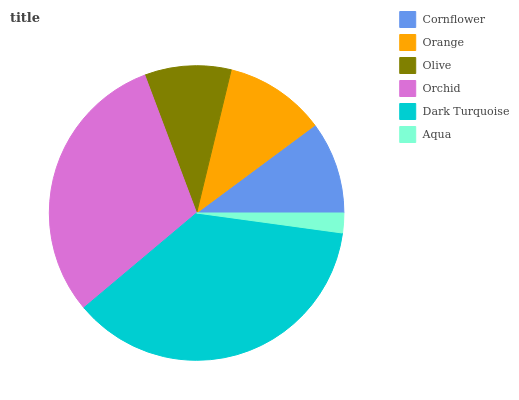Is Aqua the minimum?
Answer yes or no. Yes. Is Dark Turquoise the maximum?
Answer yes or no. Yes. Is Orange the minimum?
Answer yes or no. No. Is Orange the maximum?
Answer yes or no. No. Is Orange greater than Cornflower?
Answer yes or no. Yes. Is Cornflower less than Orange?
Answer yes or no. Yes. Is Cornflower greater than Orange?
Answer yes or no. No. Is Orange less than Cornflower?
Answer yes or no. No. Is Orange the high median?
Answer yes or no. Yes. Is Cornflower the low median?
Answer yes or no. Yes. Is Orchid the high median?
Answer yes or no. No. Is Aqua the low median?
Answer yes or no. No. 